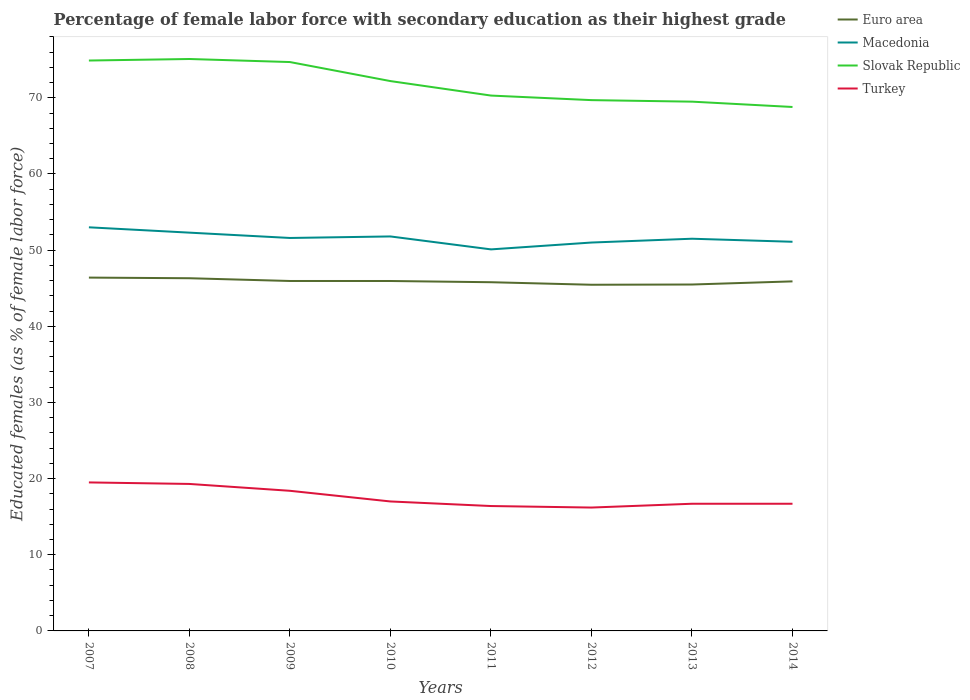How many different coloured lines are there?
Ensure brevity in your answer.  4. Does the line corresponding to Macedonia intersect with the line corresponding to Turkey?
Offer a very short reply. No. Across all years, what is the maximum percentage of female labor force with secondary education in Slovak Republic?
Keep it short and to the point. 68.8. What is the total percentage of female labor force with secondary education in Macedonia in the graph?
Offer a terse response. 1.4. What is the difference between the highest and the second highest percentage of female labor force with secondary education in Euro area?
Your answer should be compact. 0.94. What is the difference between the highest and the lowest percentage of female labor force with secondary education in Macedonia?
Your answer should be very brief. 4. Is the percentage of female labor force with secondary education in Slovak Republic strictly greater than the percentage of female labor force with secondary education in Euro area over the years?
Your response must be concise. No. What is the difference between two consecutive major ticks on the Y-axis?
Make the answer very short. 10. Does the graph contain grids?
Provide a short and direct response. No. Where does the legend appear in the graph?
Offer a very short reply. Top right. How are the legend labels stacked?
Offer a terse response. Vertical. What is the title of the graph?
Provide a short and direct response. Percentage of female labor force with secondary education as their highest grade. Does "San Marino" appear as one of the legend labels in the graph?
Your response must be concise. No. What is the label or title of the Y-axis?
Provide a short and direct response. Educated females (as % of female labor force). What is the Educated females (as % of female labor force) in Euro area in 2007?
Your answer should be very brief. 46.4. What is the Educated females (as % of female labor force) in Macedonia in 2007?
Keep it short and to the point. 53. What is the Educated females (as % of female labor force) of Slovak Republic in 2007?
Provide a succinct answer. 74.9. What is the Educated females (as % of female labor force) of Euro area in 2008?
Provide a succinct answer. 46.31. What is the Educated females (as % of female labor force) of Macedonia in 2008?
Your response must be concise. 52.3. What is the Educated females (as % of female labor force) in Slovak Republic in 2008?
Offer a terse response. 75.1. What is the Educated females (as % of female labor force) of Turkey in 2008?
Provide a short and direct response. 19.3. What is the Educated females (as % of female labor force) in Euro area in 2009?
Provide a short and direct response. 45.95. What is the Educated females (as % of female labor force) of Macedonia in 2009?
Make the answer very short. 51.6. What is the Educated females (as % of female labor force) in Slovak Republic in 2009?
Your answer should be very brief. 74.7. What is the Educated females (as % of female labor force) of Turkey in 2009?
Provide a succinct answer. 18.4. What is the Educated females (as % of female labor force) of Euro area in 2010?
Offer a very short reply. 45.95. What is the Educated females (as % of female labor force) in Macedonia in 2010?
Ensure brevity in your answer.  51.8. What is the Educated females (as % of female labor force) of Slovak Republic in 2010?
Make the answer very short. 72.2. What is the Educated females (as % of female labor force) in Euro area in 2011?
Provide a succinct answer. 45.79. What is the Educated females (as % of female labor force) in Macedonia in 2011?
Provide a succinct answer. 50.1. What is the Educated females (as % of female labor force) in Slovak Republic in 2011?
Ensure brevity in your answer.  70.3. What is the Educated females (as % of female labor force) in Turkey in 2011?
Make the answer very short. 16.4. What is the Educated females (as % of female labor force) in Euro area in 2012?
Offer a terse response. 45.46. What is the Educated females (as % of female labor force) of Macedonia in 2012?
Make the answer very short. 51. What is the Educated females (as % of female labor force) in Slovak Republic in 2012?
Ensure brevity in your answer.  69.7. What is the Educated females (as % of female labor force) of Turkey in 2012?
Your answer should be compact. 16.2. What is the Educated females (as % of female labor force) in Euro area in 2013?
Ensure brevity in your answer.  45.49. What is the Educated females (as % of female labor force) of Macedonia in 2013?
Give a very brief answer. 51.5. What is the Educated females (as % of female labor force) of Slovak Republic in 2013?
Provide a short and direct response. 69.5. What is the Educated females (as % of female labor force) in Turkey in 2013?
Keep it short and to the point. 16.7. What is the Educated females (as % of female labor force) in Euro area in 2014?
Your response must be concise. 45.9. What is the Educated females (as % of female labor force) of Macedonia in 2014?
Give a very brief answer. 51.1. What is the Educated females (as % of female labor force) in Slovak Republic in 2014?
Your answer should be compact. 68.8. What is the Educated females (as % of female labor force) in Turkey in 2014?
Ensure brevity in your answer.  16.7. Across all years, what is the maximum Educated females (as % of female labor force) in Euro area?
Ensure brevity in your answer.  46.4. Across all years, what is the maximum Educated females (as % of female labor force) in Macedonia?
Provide a short and direct response. 53. Across all years, what is the maximum Educated females (as % of female labor force) in Slovak Republic?
Your response must be concise. 75.1. Across all years, what is the maximum Educated females (as % of female labor force) of Turkey?
Provide a short and direct response. 19.5. Across all years, what is the minimum Educated females (as % of female labor force) of Euro area?
Keep it short and to the point. 45.46. Across all years, what is the minimum Educated females (as % of female labor force) in Macedonia?
Your response must be concise. 50.1. Across all years, what is the minimum Educated females (as % of female labor force) in Slovak Republic?
Give a very brief answer. 68.8. Across all years, what is the minimum Educated females (as % of female labor force) in Turkey?
Your answer should be very brief. 16.2. What is the total Educated females (as % of female labor force) of Euro area in the graph?
Your answer should be compact. 367.24. What is the total Educated females (as % of female labor force) of Macedonia in the graph?
Offer a terse response. 412.4. What is the total Educated females (as % of female labor force) in Slovak Republic in the graph?
Your answer should be compact. 575.2. What is the total Educated females (as % of female labor force) in Turkey in the graph?
Your answer should be very brief. 140.2. What is the difference between the Educated females (as % of female labor force) of Euro area in 2007 and that in 2008?
Your answer should be compact. 0.08. What is the difference between the Educated females (as % of female labor force) in Macedonia in 2007 and that in 2008?
Your answer should be compact. 0.7. What is the difference between the Educated females (as % of female labor force) in Slovak Republic in 2007 and that in 2008?
Offer a terse response. -0.2. What is the difference between the Educated females (as % of female labor force) in Turkey in 2007 and that in 2008?
Your response must be concise. 0.2. What is the difference between the Educated females (as % of female labor force) of Euro area in 2007 and that in 2009?
Ensure brevity in your answer.  0.44. What is the difference between the Educated females (as % of female labor force) in Slovak Republic in 2007 and that in 2009?
Provide a short and direct response. 0.2. What is the difference between the Educated females (as % of female labor force) in Euro area in 2007 and that in 2010?
Offer a very short reply. 0.45. What is the difference between the Educated females (as % of female labor force) in Slovak Republic in 2007 and that in 2010?
Offer a terse response. 2.7. What is the difference between the Educated females (as % of female labor force) in Turkey in 2007 and that in 2010?
Your answer should be very brief. 2.5. What is the difference between the Educated females (as % of female labor force) of Euro area in 2007 and that in 2011?
Your answer should be very brief. 0.61. What is the difference between the Educated females (as % of female labor force) in Turkey in 2007 and that in 2011?
Provide a short and direct response. 3.1. What is the difference between the Educated females (as % of female labor force) in Euro area in 2007 and that in 2012?
Provide a short and direct response. 0.94. What is the difference between the Educated females (as % of female labor force) of Turkey in 2007 and that in 2012?
Your response must be concise. 3.3. What is the difference between the Educated females (as % of female labor force) of Euro area in 2007 and that in 2013?
Offer a very short reply. 0.91. What is the difference between the Educated females (as % of female labor force) of Slovak Republic in 2007 and that in 2013?
Offer a very short reply. 5.4. What is the difference between the Educated females (as % of female labor force) in Turkey in 2007 and that in 2013?
Your answer should be very brief. 2.8. What is the difference between the Educated females (as % of female labor force) of Euro area in 2007 and that in 2014?
Provide a short and direct response. 0.5. What is the difference between the Educated females (as % of female labor force) in Macedonia in 2007 and that in 2014?
Provide a succinct answer. 1.9. What is the difference between the Educated females (as % of female labor force) of Turkey in 2007 and that in 2014?
Your answer should be very brief. 2.8. What is the difference between the Educated females (as % of female labor force) of Euro area in 2008 and that in 2009?
Offer a terse response. 0.36. What is the difference between the Educated females (as % of female labor force) in Slovak Republic in 2008 and that in 2009?
Your answer should be very brief. 0.4. What is the difference between the Educated females (as % of female labor force) in Turkey in 2008 and that in 2009?
Give a very brief answer. 0.9. What is the difference between the Educated females (as % of female labor force) of Euro area in 2008 and that in 2010?
Offer a terse response. 0.36. What is the difference between the Educated females (as % of female labor force) of Macedonia in 2008 and that in 2010?
Keep it short and to the point. 0.5. What is the difference between the Educated females (as % of female labor force) in Slovak Republic in 2008 and that in 2010?
Give a very brief answer. 2.9. What is the difference between the Educated females (as % of female labor force) in Turkey in 2008 and that in 2010?
Keep it short and to the point. 2.3. What is the difference between the Educated females (as % of female labor force) in Euro area in 2008 and that in 2011?
Offer a very short reply. 0.52. What is the difference between the Educated females (as % of female labor force) of Turkey in 2008 and that in 2011?
Your answer should be very brief. 2.9. What is the difference between the Educated females (as % of female labor force) in Euro area in 2008 and that in 2012?
Your answer should be compact. 0.86. What is the difference between the Educated females (as % of female labor force) in Euro area in 2008 and that in 2013?
Your response must be concise. 0.83. What is the difference between the Educated females (as % of female labor force) of Macedonia in 2008 and that in 2013?
Make the answer very short. 0.8. What is the difference between the Educated females (as % of female labor force) of Euro area in 2008 and that in 2014?
Your response must be concise. 0.41. What is the difference between the Educated females (as % of female labor force) in Macedonia in 2008 and that in 2014?
Ensure brevity in your answer.  1.2. What is the difference between the Educated females (as % of female labor force) of Turkey in 2008 and that in 2014?
Your answer should be very brief. 2.6. What is the difference between the Educated females (as % of female labor force) of Euro area in 2009 and that in 2010?
Provide a short and direct response. 0. What is the difference between the Educated females (as % of female labor force) in Slovak Republic in 2009 and that in 2010?
Provide a succinct answer. 2.5. What is the difference between the Educated females (as % of female labor force) of Turkey in 2009 and that in 2010?
Provide a short and direct response. 1.4. What is the difference between the Educated females (as % of female labor force) of Euro area in 2009 and that in 2011?
Ensure brevity in your answer.  0.16. What is the difference between the Educated females (as % of female labor force) of Macedonia in 2009 and that in 2011?
Offer a terse response. 1.5. What is the difference between the Educated females (as % of female labor force) in Slovak Republic in 2009 and that in 2011?
Provide a succinct answer. 4.4. What is the difference between the Educated females (as % of female labor force) of Euro area in 2009 and that in 2012?
Offer a very short reply. 0.5. What is the difference between the Educated females (as % of female labor force) in Slovak Republic in 2009 and that in 2012?
Your answer should be very brief. 5. What is the difference between the Educated females (as % of female labor force) of Euro area in 2009 and that in 2013?
Keep it short and to the point. 0.46. What is the difference between the Educated females (as % of female labor force) of Turkey in 2009 and that in 2013?
Your answer should be very brief. 1.7. What is the difference between the Educated females (as % of female labor force) of Euro area in 2009 and that in 2014?
Your response must be concise. 0.05. What is the difference between the Educated females (as % of female labor force) of Slovak Republic in 2009 and that in 2014?
Your response must be concise. 5.9. What is the difference between the Educated females (as % of female labor force) in Euro area in 2010 and that in 2011?
Offer a very short reply. 0.16. What is the difference between the Educated females (as % of female labor force) of Macedonia in 2010 and that in 2011?
Your answer should be very brief. 1.7. What is the difference between the Educated females (as % of female labor force) in Slovak Republic in 2010 and that in 2011?
Provide a short and direct response. 1.9. What is the difference between the Educated females (as % of female labor force) in Euro area in 2010 and that in 2012?
Make the answer very short. 0.49. What is the difference between the Educated females (as % of female labor force) in Macedonia in 2010 and that in 2012?
Offer a very short reply. 0.8. What is the difference between the Educated females (as % of female labor force) of Turkey in 2010 and that in 2012?
Your response must be concise. 0.8. What is the difference between the Educated females (as % of female labor force) of Euro area in 2010 and that in 2013?
Provide a succinct answer. 0.46. What is the difference between the Educated females (as % of female labor force) in Euro area in 2010 and that in 2014?
Make the answer very short. 0.05. What is the difference between the Educated females (as % of female labor force) of Turkey in 2010 and that in 2014?
Your response must be concise. 0.3. What is the difference between the Educated females (as % of female labor force) in Euro area in 2011 and that in 2012?
Provide a short and direct response. 0.33. What is the difference between the Educated females (as % of female labor force) in Slovak Republic in 2011 and that in 2012?
Make the answer very short. 0.6. What is the difference between the Educated females (as % of female labor force) of Turkey in 2011 and that in 2012?
Ensure brevity in your answer.  0.2. What is the difference between the Educated females (as % of female labor force) of Euro area in 2011 and that in 2013?
Ensure brevity in your answer.  0.3. What is the difference between the Educated females (as % of female labor force) in Macedonia in 2011 and that in 2013?
Make the answer very short. -1.4. What is the difference between the Educated females (as % of female labor force) in Slovak Republic in 2011 and that in 2013?
Your answer should be compact. 0.8. What is the difference between the Educated females (as % of female labor force) in Turkey in 2011 and that in 2013?
Your answer should be compact. -0.3. What is the difference between the Educated females (as % of female labor force) in Euro area in 2011 and that in 2014?
Keep it short and to the point. -0.11. What is the difference between the Educated females (as % of female labor force) in Macedonia in 2011 and that in 2014?
Offer a terse response. -1. What is the difference between the Educated females (as % of female labor force) of Turkey in 2011 and that in 2014?
Your response must be concise. -0.3. What is the difference between the Educated females (as % of female labor force) of Euro area in 2012 and that in 2013?
Your answer should be compact. -0.03. What is the difference between the Educated females (as % of female labor force) of Turkey in 2012 and that in 2013?
Your answer should be compact. -0.5. What is the difference between the Educated females (as % of female labor force) in Euro area in 2012 and that in 2014?
Keep it short and to the point. -0.44. What is the difference between the Educated females (as % of female labor force) of Slovak Republic in 2012 and that in 2014?
Your answer should be very brief. 0.9. What is the difference between the Educated females (as % of female labor force) in Euro area in 2013 and that in 2014?
Make the answer very short. -0.41. What is the difference between the Educated females (as % of female labor force) in Slovak Republic in 2013 and that in 2014?
Give a very brief answer. 0.7. What is the difference between the Educated females (as % of female labor force) of Turkey in 2013 and that in 2014?
Offer a terse response. 0. What is the difference between the Educated females (as % of female labor force) in Euro area in 2007 and the Educated females (as % of female labor force) in Macedonia in 2008?
Give a very brief answer. -5.9. What is the difference between the Educated females (as % of female labor force) in Euro area in 2007 and the Educated females (as % of female labor force) in Slovak Republic in 2008?
Ensure brevity in your answer.  -28.7. What is the difference between the Educated females (as % of female labor force) of Euro area in 2007 and the Educated females (as % of female labor force) of Turkey in 2008?
Offer a terse response. 27.1. What is the difference between the Educated females (as % of female labor force) in Macedonia in 2007 and the Educated females (as % of female labor force) in Slovak Republic in 2008?
Ensure brevity in your answer.  -22.1. What is the difference between the Educated females (as % of female labor force) in Macedonia in 2007 and the Educated females (as % of female labor force) in Turkey in 2008?
Offer a very short reply. 33.7. What is the difference between the Educated females (as % of female labor force) of Slovak Republic in 2007 and the Educated females (as % of female labor force) of Turkey in 2008?
Provide a short and direct response. 55.6. What is the difference between the Educated females (as % of female labor force) in Euro area in 2007 and the Educated females (as % of female labor force) in Macedonia in 2009?
Ensure brevity in your answer.  -5.2. What is the difference between the Educated females (as % of female labor force) in Euro area in 2007 and the Educated females (as % of female labor force) in Slovak Republic in 2009?
Your answer should be very brief. -28.3. What is the difference between the Educated females (as % of female labor force) in Euro area in 2007 and the Educated females (as % of female labor force) in Turkey in 2009?
Offer a terse response. 28. What is the difference between the Educated females (as % of female labor force) of Macedonia in 2007 and the Educated females (as % of female labor force) of Slovak Republic in 2009?
Keep it short and to the point. -21.7. What is the difference between the Educated females (as % of female labor force) of Macedonia in 2007 and the Educated females (as % of female labor force) of Turkey in 2009?
Your answer should be very brief. 34.6. What is the difference between the Educated females (as % of female labor force) of Slovak Republic in 2007 and the Educated females (as % of female labor force) of Turkey in 2009?
Make the answer very short. 56.5. What is the difference between the Educated females (as % of female labor force) in Euro area in 2007 and the Educated females (as % of female labor force) in Macedonia in 2010?
Your answer should be compact. -5.4. What is the difference between the Educated females (as % of female labor force) of Euro area in 2007 and the Educated females (as % of female labor force) of Slovak Republic in 2010?
Offer a terse response. -25.8. What is the difference between the Educated females (as % of female labor force) in Euro area in 2007 and the Educated females (as % of female labor force) in Turkey in 2010?
Make the answer very short. 29.4. What is the difference between the Educated females (as % of female labor force) of Macedonia in 2007 and the Educated females (as % of female labor force) of Slovak Republic in 2010?
Your response must be concise. -19.2. What is the difference between the Educated females (as % of female labor force) in Macedonia in 2007 and the Educated females (as % of female labor force) in Turkey in 2010?
Your answer should be compact. 36. What is the difference between the Educated females (as % of female labor force) of Slovak Republic in 2007 and the Educated females (as % of female labor force) of Turkey in 2010?
Provide a succinct answer. 57.9. What is the difference between the Educated females (as % of female labor force) of Euro area in 2007 and the Educated females (as % of female labor force) of Macedonia in 2011?
Your answer should be compact. -3.7. What is the difference between the Educated females (as % of female labor force) of Euro area in 2007 and the Educated females (as % of female labor force) of Slovak Republic in 2011?
Ensure brevity in your answer.  -23.9. What is the difference between the Educated females (as % of female labor force) in Euro area in 2007 and the Educated females (as % of female labor force) in Turkey in 2011?
Ensure brevity in your answer.  30. What is the difference between the Educated females (as % of female labor force) in Macedonia in 2007 and the Educated females (as % of female labor force) in Slovak Republic in 2011?
Your answer should be very brief. -17.3. What is the difference between the Educated females (as % of female labor force) of Macedonia in 2007 and the Educated females (as % of female labor force) of Turkey in 2011?
Give a very brief answer. 36.6. What is the difference between the Educated females (as % of female labor force) in Slovak Republic in 2007 and the Educated females (as % of female labor force) in Turkey in 2011?
Offer a very short reply. 58.5. What is the difference between the Educated females (as % of female labor force) in Euro area in 2007 and the Educated females (as % of female labor force) in Macedonia in 2012?
Your answer should be compact. -4.6. What is the difference between the Educated females (as % of female labor force) of Euro area in 2007 and the Educated females (as % of female labor force) of Slovak Republic in 2012?
Offer a terse response. -23.3. What is the difference between the Educated females (as % of female labor force) of Euro area in 2007 and the Educated females (as % of female labor force) of Turkey in 2012?
Give a very brief answer. 30.2. What is the difference between the Educated females (as % of female labor force) in Macedonia in 2007 and the Educated females (as % of female labor force) in Slovak Republic in 2012?
Make the answer very short. -16.7. What is the difference between the Educated females (as % of female labor force) in Macedonia in 2007 and the Educated females (as % of female labor force) in Turkey in 2012?
Your answer should be compact. 36.8. What is the difference between the Educated females (as % of female labor force) of Slovak Republic in 2007 and the Educated females (as % of female labor force) of Turkey in 2012?
Offer a terse response. 58.7. What is the difference between the Educated females (as % of female labor force) in Euro area in 2007 and the Educated females (as % of female labor force) in Macedonia in 2013?
Provide a succinct answer. -5.1. What is the difference between the Educated females (as % of female labor force) in Euro area in 2007 and the Educated females (as % of female labor force) in Slovak Republic in 2013?
Make the answer very short. -23.1. What is the difference between the Educated females (as % of female labor force) in Euro area in 2007 and the Educated females (as % of female labor force) in Turkey in 2013?
Offer a very short reply. 29.7. What is the difference between the Educated females (as % of female labor force) of Macedonia in 2007 and the Educated females (as % of female labor force) of Slovak Republic in 2013?
Provide a succinct answer. -16.5. What is the difference between the Educated females (as % of female labor force) of Macedonia in 2007 and the Educated females (as % of female labor force) of Turkey in 2013?
Keep it short and to the point. 36.3. What is the difference between the Educated females (as % of female labor force) of Slovak Republic in 2007 and the Educated females (as % of female labor force) of Turkey in 2013?
Provide a succinct answer. 58.2. What is the difference between the Educated females (as % of female labor force) of Euro area in 2007 and the Educated females (as % of female labor force) of Macedonia in 2014?
Provide a succinct answer. -4.7. What is the difference between the Educated females (as % of female labor force) of Euro area in 2007 and the Educated females (as % of female labor force) of Slovak Republic in 2014?
Your answer should be very brief. -22.4. What is the difference between the Educated females (as % of female labor force) in Euro area in 2007 and the Educated females (as % of female labor force) in Turkey in 2014?
Offer a very short reply. 29.7. What is the difference between the Educated females (as % of female labor force) in Macedonia in 2007 and the Educated females (as % of female labor force) in Slovak Republic in 2014?
Offer a very short reply. -15.8. What is the difference between the Educated females (as % of female labor force) of Macedonia in 2007 and the Educated females (as % of female labor force) of Turkey in 2014?
Your response must be concise. 36.3. What is the difference between the Educated females (as % of female labor force) of Slovak Republic in 2007 and the Educated females (as % of female labor force) of Turkey in 2014?
Provide a short and direct response. 58.2. What is the difference between the Educated females (as % of female labor force) in Euro area in 2008 and the Educated females (as % of female labor force) in Macedonia in 2009?
Provide a succinct answer. -5.29. What is the difference between the Educated females (as % of female labor force) in Euro area in 2008 and the Educated females (as % of female labor force) in Slovak Republic in 2009?
Your answer should be compact. -28.39. What is the difference between the Educated females (as % of female labor force) in Euro area in 2008 and the Educated females (as % of female labor force) in Turkey in 2009?
Offer a very short reply. 27.91. What is the difference between the Educated females (as % of female labor force) of Macedonia in 2008 and the Educated females (as % of female labor force) of Slovak Republic in 2009?
Your answer should be compact. -22.4. What is the difference between the Educated females (as % of female labor force) in Macedonia in 2008 and the Educated females (as % of female labor force) in Turkey in 2009?
Provide a short and direct response. 33.9. What is the difference between the Educated females (as % of female labor force) in Slovak Republic in 2008 and the Educated females (as % of female labor force) in Turkey in 2009?
Offer a very short reply. 56.7. What is the difference between the Educated females (as % of female labor force) in Euro area in 2008 and the Educated females (as % of female labor force) in Macedonia in 2010?
Offer a very short reply. -5.49. What is the difference between the Educated females (as % of female labor force) of Euro area in 2008 and the Educated females (as % of female labor force) of Slovak Republic in 2010?
Provide a short and direct response. -25.89. What is the difference between the Educated females (as % of female labor force) of Euro area in 2008 and the Educated females (as % of female labor force) of Turkey in 2010?
Provide a succinct answer. 29.31. What is the difference between the Educated females (as % of female labor force) in Macedonia in 2008 and the Educated females (as % of female labor force) in Slovak Republic in 2010?
Offer a terse response. -19.9. What is the difference between the Educated females (as % of female labor force) of Macedonia in 2008 and the Educated females (as % of female labor force) of Turkey in 2010?
Give a very brief answer. 35.3. What is the difference between the Educated females (as % of female labor force) of Slovak Republic in 2008 and the Educated females (as % of female labor force) of Turkey in 2010?
Your answer should be compact. 58.1. What is the difference between the Educated females (as % of female labor force) of Euro area in 2008 and the Educated females (as % of female labor force) of Macedonia in 2011?
Offer a terse response. -3.79. What is the difference between the Educated females (as % of female labor force) in Euro area in 2008 and the Educated females (as % of female labor force) in Slovak Republic in 2011?
Provide a succinct answer. -23.99. What is the difference between the Educated females (as % of female labor force) in Euro area in 2008 and the Educated females (as % of female labor force) in Turkey in 2011?
Give a very brief answer. 29.91. What is the difference between the Educated females (as % of female labor force) of Macedonia in 2008 and the Educated females (as % of female labor force) of Turkey in 2011?
Provide a short and direct response. 35.9. What is the difference between the Educated females (as % of female labor force) in Slovak Republic in 2008 and the Educated females (as % of female labor force) in Turkey in 2011?
Provide a short and direct response. 58.7. What is the difference between the Educated females (as % of female labor force) in Euro area in 2008 and the Educated females (as % of female labor force) in Macedonia in 2012?
Your answer should be compact. -4.69. What is the difference between the Educated females (as % of female labor force) in Euro area in 2008 and the Educated females (as % of female labor force) in Slovak Republic in 2012?
Keep it short and to the point. -23.39. What is the difference between the Educated females (as % of female labor force) in Euro area in 2008 and the Educated females (as % of female labor force) in Turkey in 2012?
Provide a succinct answer. 30.11. What is the difference between the Educated females (as % of female labor force) in Macedonia in 2008 and the Educated females (as % of female labor force) in Slovak Republic in 2012?
Your answer should be very brief. -17.4. What is the difference between the Educated females (as % of female labor force) of Macedonia in 2008 and the Educated females (as % of female labor force) of Turkey in 2012?
Your answer should be compact. 36.1. What is the difference between the Educated females (as % of female labor force) of Slovak Republic in 2008 and the Educated females (as % of female labor force) of Turkey in 2012?
Give a very brief answer. 58.9. What is the difference between the Educated females (as % of female labor force) of Euro area in 2008 and the Educated females (as % of female labor force) of Macedonia in 2013?
Your answer should be compact. -5.19. What is the difference between the Educated females (as % of female labor force) of Euro area in 2008 and the Educated females (as % of female labor force) of Slovak Republic in 2013?
Keep it short and to the point. -23.19. What is the difference between the Educated females (as % of female labor force) in Euro area in 2008 and the Educated females (as % of female labor force) in Turkey in 2013?
Make the answer very short. 29.61. What is the difference between the Educated females (as % of female labor force) in Macedonia in 2008 and the Educated females (as % of female labor force) in Slovak Republic in 2013?
Offer a terse response. -17.2. What is the difference between the Educated females (as % of female labor force) in Macedonia in 2008 and the Educated females (as % of female labor force) in Turkey in 2013?
Your response must be concise. 35.6. What is the difference between the Educated females (as % of female labor force) of Slovak Republic in 2008 and the Educated females (as % of female labor force) of Turkey in 2013?
Your response must be concise. 58.4. What is the difference between the Educated females (as % of female labor force) of Euro area in 2008 and the Educated females (as % of female labor force) of Macedonia in 2014?
Offer a very short reply. -4.79. What is the difference between the Educated females (as % of female labor force) in Euro area in 2008 and the Educated females (as % of female labor force) in Slovak Republic in 2014?
Your answer should be very brief. -22.49. What is the difference between the Educated females (as % of female labor force) in Euro area in 2008 and the Educated females (as % of female labor force) in Turkey in 2014?
Provide a succinct answer. 29.61. What is the difference between the Educated females (as % of female labor force) of Macedonia in 2008 and the Educated females (as % of female labor force) of Slovak Republic in 2014?
Your answer should be compact. -16.5. What is the difference between the Educated females (as % of female labor force) in Macedonia in 2008 and the Educated females (as % of female labor force) in Turkey in 2014?
Provide a short and direct response. 35.6. What is the difference between the Educated females (as % of female labor force) of Slovak Republic in 2008 and the Educated females (as % of female labor force) of Turkey in 2014?
Give a very brief answer. 58.4. What is the difference between the Educated females (as % of female labor force) of Euro area in 2009 and the Educated females (as % of female labor force) of Macedonia in 2010?
Keep it short and to the point. -5.85. What is the difference between the Educated females (as % of female labor force) in Euro area in 2009 and the Educated females (as % of female labor force) in Slovak Republic in 2010?
Your answer should be compact. -26.25. What is the difference between the Educated females (as % of female labor force) in Euro area in 2009 and the Educated females (as % of female labor force) in Turkey in 2010?
Ensure brevity in your answer.  28.95. What is the difference between the Educated females (as % of female labor force) of Macedonia in 2009 and the Educated females (as % of female labor force) of Slovak Republic in 2010?
Offer a terse response. -20.6. What is the difference between the Educated females (as % of female labor force) in Macedonia in 2009 and the Educated females (as % of female labor force) in Turkey in 2010?
Provide a short and direct response. 34.6. What is the difference between the Educated females (as % of female labor force) in Slovak Republic in 2009 and the Educated females (as % of female labor force) in Turkey in 2010?
Keep it short and to the point. 57.7. What is the difference between the Educated females (as % of female labor force) of Euro area in 2009 and the Educated females (as % of female labor force) of Macedonia in 2011?
Ensure brevity in your answer.  -4.15. What is the difference between the Educated females (as % of female labor force) of Euro area in 2009 and the Educated females (as % of female labor force) of Slovak Republic in 2011?
Provide a succinct answer. -24.35. What is the difference between the Educated females (as % of female labor force) in Euro area in 2009 and the Educated females (as % of female labor force) in Turkey in 2011?
Give a very brief answer. 29.55. What is the difference between the Educated females (as % of female labor force) of Macedonia in 2009 and the Educated females (as % of female labor force) of Slovak Republic in 2011?
Ensure brevity in your answer.  -18.7. What is the difference between the Educated females (as % of female labor force) of Macedonia in 2009 and the Educated females (as % of female labor force) of Turkey in 2011?
Your answer should be compact. 35.2. What is the difference between the Educated females (as % of female labor force) in Slovak Republic in 2009 and the Educated females (as % of female labor force) in Turkey in 2011?
Your answer should be very brief. 58.3. What is the difference between the Educated females (as % of female labor force) of Euro area in 2009 and the Educated females (as % of female labor force) of Macedonia in 2012?
Your answer should be compact. -5.05. What is the difference between the Educated females (as % of female labor force) in Euro area in 2009 and the Educated females (as % of female labor force) in Slovak Republic in 2012?
Offer a terse response. -23.75. What is the difference between the Educated females (as % of female labor force) of Euro area in 2009 and the Educated females (as % of female labor force) of Turkey in 2012?
Your answer should be very brief. 29.75. What is the difference between the Educated females (as % of female labor force) of Macedonia in 2009 and the Educated females (as % of female labor force) of Slovak Republic in 2012?
Give a very brief answer. -18.1. What is the difference between the Educated females (as % of female labor force) in Macedonia in 2009 and the Educated females (as % of female labor force) in Turkey in 2012?
Ensure brevity in your answer.  35.4. What is the difference between the Educated females (as % of female labor force) of Slovak Republic in 2009 and the Educated females (as % of female labor force) of Turkey in 2012?
Make the answer very short. 58.5. What is the difference between the Educated females (as % of female labor force) of Euro area in 2009 and the Educated females (as % of female labor force) of Macedonia in 2013?
Your response must be concise. -5.55. What is the difference between the Educated females (as % of female labor force) in Euro area in 2009 and the Educated females (as % of female labor force) in Slovak Republic in 2013?
Ensure brevity in your answer.  -23.55. What is the difference between the Educated females (as % of female labor force) in Euro area in 2009 and the Educated females (as % of female labor force) in Turkey in 2013?
Offer a terse response. 29.25. What is the difference between the Educated females (as % of female labor force) in Macedonia in 2009 and the Educated females (as % of female labor force) in Slovak Republic in 2013?
Your answer should be compact. -17.9. What is the difference between the Educated females (as % of female labor force) in Macedonia in 2009 and the Educated females (as % of female labor force) in Turkey in 2013?
Offer a very short reply. 34.9. What is the difference between the Educated females (as % of female labor force) in Euro area in 2009 and the Educated females (as % of female labor force) in Macedonia in 2014?
Keep it short and to the point. -5.15. What is the difference between the Educated females (as % of female labor force) of Euro area in 2009 and the Educated females (as % of female labor force) of Slovak Republic in 2014?
Keep it short and to the point. -22.85. What is the difference between the Educated females (as % of female labor force) in Euro area in 2009 and the Educated females (as % of female labor force) in Turkey in 2014?
Offer a very short reply. 29.25. What is the difference between the Educated females (as % of female labor force) of Macedonia in 2009 and the Educated females (as % of female labor force) of Slovak Republic in 2014?
Your answer should be very brief. -17.2. What is the difference between the Educated females (as % of female labor force) in Macedonia in 2009 and the Educated females (as % of female labor force) in Turkey in 2014?
Offer a terse response. 34.9. What is the difference between the Educated females (as % of female labor force) of Euro area in 2010 and the Educated females (as % of female labor force) of Macedonia in 2011?
Ensure brevity in your answer.  -4.15. What is the difference between the Educated females (as % of female labor force) in Euro area in 2010 and the Educated females (as % of female labor force) in Slovak Republic in 2011?
Your answer should be very brief. -24.35. What is the difference between the Educated females (as % of female labor force) of Euro area in 2010 and the Educated females (as % of female labor force) of Turkey in 2011?
Provide a succinct answer. 29.55. What is the difference between the Educated females (as % of female labor force) in Macedonia in 2010 and the Educated females (as % of female labor force) in Slovak Republic in 2011?
Provide a short and direct response. -18.5. What is the difference between the Educated females (as % of female labor force) of Macedonia in 2010 and the Educated females (as % of female labor force) of Turkey in 2011?
Provide a succinct answer. 35.4. What is the difference between the Educated females (as % of female labor force) of Slovak Republic in 2010 and the Educated females (as % of female labor force) of Turkey in 2011?
Make the answer very short. 55.8. What is the difference between the Educated females (as % of female labor force) of Euro area in 2010 and the Educated females (as % of female labor force) of Macedonia in 2012?
Offer a very short reply. -5.05. What is the difference between the Educated females (as % of female labor force) in Euro area in 2010 and the Educated females (as % of female labor force) in Slovak Republic in 2012?
Ensure brevity in your answer.  -23.75. What is the difference between the Educated females (as % of female labor force) of Euro area in 2010 and the Educated females (as % of female labor force) of Turkey in 2012?
Offer a very short reply. 29.75. What is the difference between the Educated females (as % of female labor force) in Macedonia in 2010 and the Educated females (as % of female labor force) in Slovak Republic in 2012?
Provide a succinct answer. -17.9. What is the difference between the Educated females (as % of female labor force) of Macedonia in 2010 and the Educated females (as % of female labor force) of Turkey in 2012?
Ensure brevity in your answer.  35.6. What is the difference between the Educated females (as % of female labor force) of Euro area in 2010 and the Educated females (as % of female labor force) of Macedonia in 2013?
Offer a terse response. -5.55. What is the difference between the Educated females (as % of female labor force) of Euro area in 2010 and the Educated females (as % of female labor force) of Slovak Republic in 2013?
Keep it short and to the point. -23.55. What is the difference between the Educated females (as % of female labor force) of Euro area in 2010 and the Educated females (as % of female labor force) of Turkey in 2013?
Make the answer very short. 29.25. What is the difference between the Educated females (as % of female labor force) in Macedonia in 2010 and the Educated females (as % of female labor force) in Slovak Republic in 2013?
Your answer should be compact. -17.7. What is the difference between the Educated females (as % of female labor force) in Macedonia in 2010 and the Educated females (as % of female labor force) in Turkey in 2013?
Offer a terse response. 35.1. What is the difference between the Educated females (as % of female labor force) of Slovak Republic in 2010 and the Educated females (as % of female labor force) of Turkey in 2013?
Keep it short and to the point. 55.5. What is the difference between the Educated females (as % of female labor force) of Euro area in 2010 and the Educated females (as % of female labor force) of Macedonia in 2014?
Your answer should be compact. -5.15. What is the difference between the Educated females (as % of female labor force) in Euro area in 2010 and the Educated females (as % of female labor force) in Slovak Republic in 2014?
Make the answer very short. -22.85. What is the difference between the Educated females (as % of female labor force) of Euro area in 2010 and the Educated females (as % of female labor force) of Turkey in 2014?
Offer a very short reply. 29.25. What is the difference between the Educated females (as % of female labor force) of Macedonia in 2010 and the Educated females (as % of female labor force) of Turkey in 2014?
Give a very brief answer. 35.1. What is the difference between the Educated females (as % of female labor force) in Slovak Republic in 2010 and the Educated females (as % of female labor force) in Turkey in 2014?
Provide a short and direct response. 55.5. What is the difference between the Educated females (as % of female labor force) in Euro area in 2011 and the Educated females (as % of female labor force) in Macedonia in 2012?
Your response must be concise. -5.21. What is the difference between the Educated females (as % of female labor force) in Euro area in 2011 and the Educated females (as % of female labor force) in Slovak Republic in 2012?
Your answer should be compact. -23.91. What is the difference between the Educated females (as % of female labor force) of Euro area in 2011 and the Educated females (as % of female labor force) of Turkey in 2012?
Your answer should be very brief. 29.59. What is the difference between the Educated females (as % of female labor force) of Macedonia in 2011 and the Educated females (as % of female labor force) of Slovak Republic in 2012?
Make the answer very short. -19.6. What is the difference between the Educated females (as % of female labor force) of Macedonia in 2011 and the Educated females (as % of female labor force) of Turkey in 2012?
Keep it short and to the point. 33.9. What is the difference between the Educated females (as % of female labor force) in Slovak Republic in 2011 and the Educated females (as % of female labor force) in Turkey in 2012?
Give a very brief answer. 54.1. What is the difference between the Educated females (as % of female labor force) of Euro area in 2011 and the Educated females (as % of female labor force) of Macedonia in 2013?
Offer a terse response. -5.71. What is the difference between the Educated females (as % of female labor force) of Euro area in 2011 and the Educated females (as % of female labor force) of Slovak Republic in 2013?
Provide a succinct answer. -23.71. What is the difference between the Educated females (as % of female labor force) in Euro area in 2011 and the Educated females (as % of female labor force) in Turkey in 2013?
Your answer should be very brief. 29.09. What is the difference between the Educated females (as % of female labor force) of Macedonia in 2011 and the Educated females (as % of female labor force) of Slovak Republic in 2013?
Keep it short and to the point. -19.4. What is the difference between the Educated females (as % of female labor force) of Macedonia in 2011 and the Educated females (as % of female labor force) of Turkey in 2013?
Ensure brevity in your answer.  33.4. What is the difference between the Educated females (as % of female labor force) of Slovak Republic in 2011 and the Educated females (as % of female labor force) of Turkey in 2013?
Keep it short and to the point. 53.6. What is the difference between the Educated females (as % of female labor force) in Euro area in 2011 and the Educated females (as % of female labor force) in Macedonia in 2014?
Provide a short and direct response. -5.31. What is the difference between the Educated females (as % of female labor force) of Euro area in 2011 and the Educated females (as % of female labor force) of Slovak Republic in 2014?
Keep it short and to the point. -23.01. What is the difference between the Educated females (as % of female labor force) of Euro area in 2011 and the Educated females (as % of female labor force) of Turkey in 2014?
Make the answer very short. 29.09. What is the difference between the Educated females (as % of female labor force) of Macedonia in 2011 and the Educated females (as % of female labor force) of Slovak Republic in 2014?
Your answer should be compact. -18.7. What is the difference between the Educated females (as % of female labor force) of Macedonia in 2011 and the Educated females (as % of female labor force) of Turkey in 2014?
Keep it short and to the point. 33.4. What is the difference between the Educated females (as % of female labor force) in Slovak Republic in 2011 and the Educated females (as % of female labor force) in Turkey in 2014?
Your answer should be very brief. 53.6. What is the difference between the Educated females (as % of female labor force) in Euro area in 2012 and the Educated females (as % of female labor force) in Macedonia in 2013?
Keep it short and to the point. -6.04. What is the difference between the Educated females (as % of female labor force) in Euro area in 2012 and the Educated females (as % of female labor force) in Slovak Republic in 2013?
Your answer should be compact. -24.04. What is the difference between the Educated females (as % of female labor force) in Euro area in 2012 and the Educated females (as % of female labor force) in Turkey in 2013?
Your answer should be compact. 28.76. What is the difference between the Educated females (as % of female labor force) in Macedonia in 2012 and the Educated females (as % of female labor force) in Slovak Republic in 2013?
Keep it short and to the point. -18.5. What is the difference between the Educated females (as % of female labor force) of Macedonia in 2012 and the Educated females (as % of female labor force) of Turkey in 2013?
Offer a terse response. 34.3. What is the difference between the Educated females (as % of female labor force) of Euro area in 2012 and the Educated females (as % of female labor force) of Macedonia in 2014?
Offer a terse response. -5.64. What is the difference between the Educated females (as % of female labor force) of Euro area in 2012 and the Educated females (as % of female labor force) of Slovak Republic in 2014?
Provide a short and direct response. -23.34. What is the difference between the Educated females (as % of female labor force) of Euro area in 2012 and the Educated females (as % of female labor force) of Turkey in 2014?
Give a very brief answer. 28.76. What is the difference between the Educated females (as % of female labor force) in Macedonia in 2012 and the Educated females (as % of female labor force) in Slovak Republic in 2014?
Ensure brevity in your answer.  -17.8. What is the difference between the Educated females (as % of female labor force) of Macedonia in 2012 and the Educated females (as % of female labor force) of Turkey in 2014?
Offer a very short reply. 34.3. What is the difference between the Educated females (as % of female labor force) of Slovak Republic in 2012 and the Educated females (as % of female labor force) of Turkey in 2014?
Provide a short and direct response. 53. What is the difference between the Educated females (as % of female labor force) of Euro area in 2013 and the Educated females (as % of female labor force) of Macedonia in 2014?
Your response must be concise. -5.61. What is the difference between the Educated females (as % of female labor force) of Euro area in 2013 and the Educated females (as % of female labor force) of Slovak Republic in 2014?
Provide a short and direct response. -23.31. What is the difference between the Educated females (as % of female labor force) in Euro area in 2013 and the Educated females (as % of female labor force) in Turkey in 2014?
Your answer should be very brief. 28.79. What is the difference between the Educated females (as % of female labor force) of Macedonia in 2013 and the Educated females (as % of female labor force) of Slovak Republic in 2014?
Make the answer very short. -17.3. What is the difference between the Educated females (as % of female labor force) in Macedonia in 2013 and the Educated females (as % of female labor force) in Turkey in 2014?
Offer a terse response. 34.8. What is the difference between the Educated females (as % of female labor force) of Slovak Republic in 2013 and the Educated females (as % of female labor force) of Turkey in 2014?
Keep it short and to the point. 52.8. What is the average Educated females (as % of female labor force) of Euro area per year?
Offer a terse response. 45.91. What is the average Educated females (as % of female labor force) in Macedonia per year?
Give a very brief answer. 51.55. What is the average Educated females (as % of female labor force) in Slovak Republic per year?
Your answer should be very brief. 71.9. What is the average Educated females (as % of female labor force) of Turkey per year?
Give a very brief answer. 17.52. In the year 2007, what is the difference between the Educated females (as % of female labor force) in Euro area and Educated females (as % of female labor force) in Macedonia?
Provide a succinct answer. -6.6. In the year 2007, what is the difference between the Educated females (as % of female labor force) of Euro area and Educated females (as % of female labor force) of Slovak Republic?
Offer a terse response. -28.5. In the year 2007, what is the difference between the Educated females (as % of female labor force) of Euro area and Educated females (as % of female labor force) of Turkey?
Provide a succinct answer. 26.9. In the year 2007, what is the difference between the Educated females (as % of female labor force) in Macedonia and Educated females (as % of female labor force) in Slovak Republic?
Offer a very short reply. -21.9. In the year 2007, what is the difference between the Educated females (as % of female labor force) in Macedonia and Educated females (as % of female labor force) in Turkey?
Offer a very short reply. 33.5. In the year 2007, what is the difference between the Educated females (as % of female labor force) in Slovak Republic and Educated females (as % of female labor force) in Turkey?
Your response must be concise. 55.4. In the year 2008, what is the difference between the Educated females (as % of female labor force) in Euro area and Educated females (as % of female labor force) in Macedonia?
Provide a short and direct response. -5.99. In the year 2008, what is the difference between the Educated females (as % of female labor force) of Euro area and Educated females (as % of female labor force) of Slovak Republic?
Your answer should be compact. -28.79. In the year 2008, what is the difference between the Educated females (as % of female labor force) of Euro area and Educated females (as % of female labor force) of Turkey?
Give a very brief answer. 27.01. In the year 2008, what is the difference between the Educated females (as % of female labor force) in Macedonia and Educated females (as % of female labor force) in Slovak Republic?
Offer a terse response. -22.8. In the year 2008, what is the difference between the Educated females (as % of female labor force) in Macedonia and Educated females (as % of female labor force) in Turkey?
Give a very brief answer. 33. In the year 2008, what is the difference between the Educated females (as % of female labor force) in Slovak Republic and Educated females (as % of female labor force) in Turkey?
Provide a succinct answer. 55.8. In the year 2009, what is the difference between the Educated females (as % of female labor force) of Euro area and Educated females (as % of female labor force) of Macedonia?
Offer a terse response. -5.65. In the year 2009, what is the difference between the Educated females (as % of female labor force) of Euro area and Educated females (as % of female labor force) of Slovak Republic?
Your response must be concise. -28.75. In the year 2009, what is the difference between the Educated females (as % of female labor force) of Euro area and Educated females (as % of female labor force) of Turkey?
Make the answer very short. 27.55. In the year 2009, what is the difference between the Educated females (as % of female labor force) of Macedonia and Educated females (as % of female labor force) of Slovak Republic?
Your answer should be very brief. -23.1. In the year 2009, what is the difference between the Educated females (as % of female labor force) in Macedonia and Educated females (as % of female labor force) in Turkey?
Your answer should be compact. 33.2. In the year 2009, what is the difference between the Educated females (as % of female labor force) of Slovak Republic and Educated females (as % of female labor force) of Turkey?
Ensure brevity in your answer.  56.3. In the year 2010, what is the difference between the Educated females (as % of female labor force) in Euro area and Educated females (as % of female labor force) in Macedonia?
Give a very brief answer. -5.85. In the year 2010, what is the difference between the Educated females (as % of female labor force) of Euro area and Educated females (as % of female labor force) of Slovak Republic?
Your answer should be compact. -26.25. In the year 2010, what is the difference between the Educated females (as % of female labor force) of Euro area and Educated females (as % of female labor force) of Turkey?
Your answer should be compact. 28.95. In the year 2010, what is the difference between the Educated females (as % of female labor force) in Macedonia and Educated females (as % of female labor force) in Slovak Republic?
Your response must be concise. -20.4. In the year 2010, what is the difference between the Educated females (as % of female labor force) of Macedonia and Educated females (as % of female labor force) of Turkey?
Your response must be concise. 34.8. In the year 2010, what is the difference between the Educated females (as % of female labor force) in Slovak Republic and Educated females (as % of female labor force) in Turkey?
Your answer should be very brief. 55.2. In the year 2011, what is the difference between the Educated females (as % of female labor force) of Euro area and Educated females (as % of female labor force) of Macedonia?
Make the answer very short. -4.31. In the year 2011, what is the difference between the Educated females (as % of female labor force) in Euro area and Educated females (as % of female labor force) in Slovak Republic?
Ensure brevity in your answer.  -24.51. In the year 2011, what is the difference between the Educated females (as % of female labor force) of Euro area and Educated females (as % of female labor force) of Turkey?
Give a very brief answer. 29.39. In the year 2011, what is the difference between the Educated females (as % of female labor force) of Macedonia and Educated females (as % of female labor force) of Slovak Republic?
Your answer should be compact. -20.2. In the year 2011, what is the difference between the Educated females (as % of female labor force) of Macedonia and Educated females (as % of female labor force) of Turkey?
Keep it short and to the point. 33.7. In the year 2011, what is the difference between the Educated females (as % of female labor force) in Slovak Republic and Educated females (as % of female labor force) in Turkey?
Make the answer very short. 53.9. In the year 2012, what is the difference between the Educated females (as % of female labor force) in Euro area and Educated females (as % of female labor force) in Macedonia?
Your answer should be compact. -5.54. In the year 2012, what is the difference between the Educated females (as % of female labor force) of Euro area and Educated females (as % of female labor force) of Slovak Republic?
Provide a short and direct response. -24.24. In the year 2012, what is the difference between the Educated females (as % of female labor force) in Euro area and Educated females (as % of female labor force) in Turkey?
Offer a very short reply. 29.26. In the year 2012, what is the difference between the Educated females (as % of female labor force) in Macedonia and Educated females (as % of female labor force) in Slovak Republic?
Offer a very short reply. -18.7. In the year 2012, what is the difference between the Educated females (as % of female labor force) in Macedonia and Educated females (as % of female labor force) in Turkey?
Offer a very short reply. 34.8. In the year 2012, what is the difference between the Educated females (as % of female labor force) of Slovak Republic and Educated females (as % of female labor force) of Turkey?
Keep it short and to the point. 53.5. In the year 2013, what is the difference between the Educated females (as % of female labor force) in Euro area and Educated females (as % of female labor force) in Macedonia?
Make the answer very short. -6.01. In the year 2013, what is the difference between the Educated females (as % of female labor force) in Euro area and Educated females (as % of female labor force) in Slovak Republic?
Offer a very short reply. -24.01. In the year 2013, what is the difference between the Educated females (as % of female labor force) in Euro area and Educated females (as % of female labor force) in Turkey?
Offer a very short reply. 28.79. In the year 2013, what is the difference between the Educated females (as % of female labor force) in Macedonia and Educated females (as % of female labor force) in Slovak Republic?
Offer a terse response. -18. In the year 2013, what is the difference between the Educated females (as % of female labor force) of Macedonia and Educated females (as % of female labor force) of Turkey?
Offer a very short reply. 34.8. In the year 2013, what is the difference between the Educated females (as % of female labor force) of Slovak Republic and Educated females (as % of female labor force) of Turkey?
Your response must be concise. 52.8. In the year 2014, what is the difference between the Educated females (as % of female labor force) of Euro area and Educated females (as % of female labor force) of Macedonia?
Give a very brief answer. -5.2. In the year 2014, what is the difference between the Educated females (as % of female labor force) of Euro area and Educated females (as % of female labor force) of Slovak Republic?
Keep it short and to the point. -22.9. In the year 2014, what is the difference between the Educated females (as % of female labor force) in Euro area and Educated females (as % of female labor force) in Turkey?
Provide a succinct answer. 29.2. In the year 2014, what is the difference between the Educated females (as % of female labor force) of Macedonia and Educated females (as % of female labor force) of Slovak Republic?
Ensure brevity in your answer.  -17.7. In the year 2014, what is the difference between the Educated females (as % of female labor force) in Macedonia and Educated females (as % of female labor force) in Turkey?
Offer a very short reply. 34.4. In the year 2014, what is the difference between the Educated females (as % of female labor force) in Slovak Republic and Educated females (as % of female labor force) in Turkey?
Your answer should be compact. 52.1. What is the ratio of the Educated females (as % of female labor force) of Euro area in 2007 to that in 2008?
Your response must be concise. 1. What is the ratio of the Educated females (as % of female labor force) of Macedonia in 2007 to that in 2008?
Give a very brief answer. 1.01. What is the ratio of the Educated females (as % of female labor force) in Slovak Republic in 2007 to that in 2008?
Give a very brief answer. 1. What is the ratio of the Educated females (as % of female labor force) of Turkey in 2007 to that in 2008?
Offer a very short reply. 1.01. What is the ratio of the Educated females (as % of female labor force) in Euro area in 2007 to that in 2009?
Make the answer very short. 1.01. What is the ratio of the Educated females (as % of female labor force) in Macedonia in 2007 to that in 2009?
Keep it short and to the point. 1.03. What is the ratio of the Educated females (as % of female labor force) in Turkey in 2007 to that in 2009?
Keep it short and to the point. 1.06. What is the ratio of the Educated females (as % of female labor force) in Euro area in 2007 to that in 2010?
Your answer should be very brief. 1.01. What is the ratio of the Educated females (as % of female labor force) of Macedonia in 2007 to that in 2010?
Your response must be concise. 1.02. What is the ratio of the Educated females (as % of female labor force) in Slovak Republic in 2007 to that in 2010?
Your answer should be compact. 1.04. What is the ratio of the Educated females (as % of female labor force) in Turkey in 2007 to that in 2010?
Provide a succinct answer. 1.15. What is the ratio of the Educated females (as % of female labor force) in Euro area in 2007 to that in 2011?
Provide a short and direct response. 1.01. What is the ratio of the Educated females (as % of female labor force) of Macedonia in 2007 to that in 2011?
Keep it short and to the point. 1.06. What is the ratio of the Educated females (as % of female labor force) of Slovak Republic in 2007 to that in 2011?
Offer a terse response. 1.07. What is the ratio of the Educated females (as % of female labor force) of Turkey in 2007 to that in 2011?
Offer a very short reply. 1.19. What is the ratio of the Educated females (as % of female labor force) in Euro area in 2007 to that in 2012?
Offer a very short reply. 1.02. What is the ratio of the Educated females (as % of female labor force) of Macedonia in 2007 to that in 2012?
Your answer should be compact. 1.04. What is the ratio of the Educated females (as % of female labor force) of Slovak Republic in 2007 to that in 2012?
Provide a succinct answer. 1.07. What is the ratio of the Educated females (as % of female labor force) in Turkey in 2007 to that in 2012?
Give a very brief answer. 1.2. What is the ratio of the Educated females (as % of female labor force) in Macedonia in 2007 to that in 2013?
Keep it short and to the point. 1.03. What is the ratio of the Educated females (as % of female labor force) in Slovak Republic in 2007 to that in 2013?
Offer a very short reply. 1.08. What is the ratio of the Educated females (as % of female labor force) of Turkey in 2007 to that in 2013?
Your answer should be very brief. 1.17. What is the ratio of the Educated females (as % of female labor force) in Euro area in 2007 to that in 2014?
Give a very brief answer. 1.01. What is the ratio of the Educated females (as % of female labor force) of Macedonia in 2007 to that in 2014?
Ensure brevity in your answer.  1.04. What is the ratio of the Educated females (as % of female labor force) in Slovak Republic in 2007 to that in 2014?
Provide a short and direct response. 1.09. What is the ratio of the Educated females (as % of female labor force) in Turkey in 2007 to that in 2014?
Offer a very short reply. 1.17. What is the ratio of the Educated females (as % of female labor force) in Euro area in 2008 to that in 2009?
Offer a very short reply. 1.01. What is the ratio of the Educated females (as % of female labor force) of Macedonia in 2008 to that in 2009?
Your answer should be very brief. 1.01. What is the ratio of the Educated females (as % of female labor force) of Slovak Republic in 2008 to that in 2009?
Ensure brevity in your answer.  1.01. What is the ratio of the Educated females (as % of female labor force) of Turkey in 2008 to that in 2009?
Keep it short and to the point. 1.05. What is the ratio of the Educated females (as % of female labor force) of Euro area in 2008 to that in 2010?
Your answer should be compact. 1.01. What is the ratio of the Educated females (as % of female labor force) in Macedonia in 2008 to that in 2010?
Your answer should be compact. 1.01. What is the ratio of the Educated females (as % of female labor force) in Slovak Republic in 2008 to that in 2010?
Your answer should be very brief. 1.04. What is the ratio of the Educated females (as % of female labor force) of Turkey in 2008 to that in 2010?
Your response must be concise. 1.14. What is the ratio of the Educated females (as % of female labor force) of Euro area in 2008 to that in 2011?
Ensure brevity in your answer.  1.01. What is the ratio of the Educated females (as % of female labor force) of Macedonia in 2008 to that in 2011?
Ensure brevity in your answer.  1.04. What is the ratio of the Educated females (as % of female labor force) of Slovak Republic in 2008 to that in 2011?
Your answer should be compact. 1.07. What is the ratio of the Educated females (as % of female labor force) of Turkey in 2008 to that in 2011?
Give a very brief answer. 1.18. What is the ratio of the Educated females (as % of female labor force) in Euro area in 2008 to that in 2012?
Your response must be concise. 1.02. What is the ratio of the Educated females (as % of female labor force) in Macedonia in 2008 to that in 2012?
Offer a very short reply. 1.03. What is the ratio of the Educated females (as % of female labor force) of Slovak Republic in 2008 to that in 2012?
Provide a succinct answer. 1.08. What is the ratio of the Educated females (as % of female labor force) in Turkey in 2008 to that in 2012?
Give a very brief answer. 1.19. What is the ratio of the Educated females (as % of female labor force) in Euro area in 2008 to that in 2013?
Your answer should be very brief. 1.02. What is the ratio of the Educated females (as % of female labor force) in Macedonia in 2008 to that in 2013?
Give a very brief answer. 1.02. What is the ratio of the Educated females (as % of female labor force) in Slovak Republic in 2008 to that in 2013?
Keep it short and to the point. 1.08. What is the ratio of the Educated females (as % of female labor force) in Turkey in 2008 to that in 2013?
Offer a very short reply. 1.16. What is the ratio of the Educated females (as % of female labor force) in Macedonia in 2008 to that in 2014?
Keep it short and to the point. 1.02. What is the ratio of the Educated females (as % of female labor force) of Slovak Republic in 2008 to that in 2014?
Offer a very short reply. 1.09. What is the ratio of the Educated females (as % of female labor force) in Turkey in 2008 to that in 2014?
Your answer should be very brief. 1.16. What is the ratio of the Educated females (as % of female labor force) in Euro area in 2009 to that in 2010?
Give a very brief answer. 1. What is the ratio of the Educated females (as % of female labor force) of Macedonia in 2009 to that in 2010?
Make the answer very short. 1. What is the ratio of the Educated females (as % of female labor force) of Slovak Republic in 2009 to that in 2010?
Provide a succinct answer. 1.03. What is the ratio of the Educated females (as % of female labor force) of Turkey in 2009 to that in 2010?
Offer a terse response. 1.08. What is the ratio of the Educated females (as % of female labor force) of Macedonia in 2009 to that in 2011?
Give a very brief answer. 1.03. What is the ratio of the Educated females (as % of female labor force) in Slovak Republic in 2009 to that in 2011?
Provide a short and direct response. 1.06. What is the ratio of the Educated females (as % of female labor force) in Turkey in 2009 to that in 2011?
Provide a succinct answer. 1.12. What is the ratio of the Educated females (as % of female labor force) in Euro area in 2009 to that in 2012?
Make the answer very short. 1.01. What is the ratio of the Educated females (as % of female labor force) in Macedonia in 2009 to that in 2012?
Keep it short and to the point. 1.01. What is the ratio of the Educated females (as % of female labor force) of Slovak Republic in 2009 to that in 2012?
Provide a succinct answer. 1.07. What is the ratio of the Educated females (as % of female labor force) in Turkey in 2009 to that in 2012?
Make the answer very short. 1.14. What is the ratio of the Educated females (as % of female labor force) in Euro area in 2009 to that in 2013?
Give a very brief answer. 1.01. What is the ratio of the Educated females (as % of female labor force) of Slovak Republic in 2009 to that in 2013?
Provide a succinct answer. 1.07. What is the ratio of the Educated females (as % of female labor force) of Turkey in 2009 to that in 2013?
Give a very brief answer. 1.1. What is the ratio of the Educated females (as % of female labor force) of Euro area in 2009 to that in 2014?
Keep it short and to the point. 1. What is the ratio of the Educated females (as % of female labor force) in Macedonia in 2009 to that in 2014?
Your answer should be compact. 1.01. What is the ratio of the Educated females (as % of female labor force) of Slovak Republic in 2009 to that in 2014?
Provide a short and direct response. 1.09. What is the ratio of the Educated females (as % of female labor force) in Turkey in 2009 to that in 2014?
Give a very brief answer. 1.1. What is the ratio of the Educated females (as % of female labor force) in Euro area in 2010 to that in 2011?
Make the answer very short. 1. What is the ratio of the Educated females (as % of female labor force) in Macedonia in 2010 to that in 2011?
Make the answer very short. 1.03. What is the ratio of the Educated females (as % of female labor force) of Slovak Republic in 2010 to that in 2011?
Ensure brevity in your answer.  1.03. What is the ratio of the Educated females (as % of female labor force) in Turkey in 2010 to that in 2011?
Your answer should be very brief. 1.04. What is the ratio of the Educated females (as % of female labor force) in Euro area in 2010 to that in 2012?
Keep it short and to the point. 1.01. What is the ratio of the Educated females (as % of female labor force) of Macedonia in 2010 to that in 2012?
Offer a terse response. 1.02. What is the ratio of the Educated females (as % of female labor force) in Slovak Republic in 2010 to that in 2012?
Make the answer very short. 1.04. What is the ratio of the Educated females (as % of female labor force) of Turkey in 2010 to that in 2012?
Make the answer very short. 1.05. What is the ratio of the Educated females (as % of female labor force) of Euro area in 2010 to that in 2013?
Your response must be concise. 1.01. What is the ratio of the Educated females (as % of female labor force) in Macedonia in 2010 to that in 2013?
Your answer should be very brief. 1.01. What is the ratio of the Educated females (as % of female labor force) in Slovak Republic in 2010 to that in 2013?
Provide a short and direct response. 1.04. What is the ratio of the Educated females (as % of female labor force) in Turkey in 2010 to that in 2013?
Give a very brief answer. 1.02. What is the ratio of the Educated females (as % of female labor force) of Euro area in 2010 to that in 2014?
Provide a succinct answer. 1. What is the ratio of the Educated females (as % of female labor force) of Macedonia in 2010 to that in 2014?
Keep it short and to the point. 1.01. What is the ratio of the Educated females (as % of female labor force) in Slovak Republic in 2010 to that in 2014?
Give a very brief answer. 1.05. What is the ratio of the Educated females (as % of female labor force) of Euro area in 2011 to that in 2012?
Ensure brevity in your answer.  1.01. What is the ratio of the Educated females (as % of female labor force) of Macedonia in 2011 to that in 2012?
Make the answer very short. 0.98. What is the ratio of the Educated females (as % of female labor force) of Slovak Republic in 2011 to that in 2012?
Provide a short and direct response. 1.01. What is the ratio of the Educated females (as % of female labor force) of Turkey in 2011 to that in 2012?
Ensure brevity in your answer.  1.01. What is the ratio of the Educated females (as % of female labor force) in Euro area in 2011 to that in 2013?
Your answer should be compact. 1.01. What is the ratio of the Educated females (as % of female labor force) in Macedonia in 2011 to that in 2013?
Your answer should be compact. 0.97. What is the ratio of the Educated females (as % of female labor force) of Slovak Republic in 2011 to that in 2013?
Offer a terse response. 1.01. What is the ratio of the Educated females (as % of female labor force) in Macedonia in 2011 to that in 2014?
Your answer should be very brief. 0.98. What is the ratio of the Educated females (as % of female labor force) of Slovak Republic in 2011 to that in 2014?
Offer a terse response. 1.02. What is the ratio of the Educated females (as % of female labor force) in Turkey in 2011 to that in 2014?
Make the answer very short. 0.98. What is the ratio of the Educated females (as % of female labor force) of Euro area in 2012 to that in 2013?
Offer a terse response. 1. What is the ratio of the Educated females (as % of female labor force) of Macedonia in 2012 to that in 2013?
Provide a succinct answer. 0.99. What is the ratio of the Educated females (as % of female labor force) in Turkey in 2012 to that in 2013?
Keep it short and to the point. 0.97. What is the ratio of the Educated females (as % of female labor force) in Euro area in 2012 to that in 2014?
Your answer should be compact. 0.99. What is the ratio of the Educated females (as % of female labor force) of Macedonia in 2012 to that in 2014?
Your answer should be very brief. 1. What is the ratio of the Educated females (as % of female labor force) in Slovak Republic in 2012 to that in 2014?
Offer a terse response. 1.01. What is the ratio of the Educated females (as % of female labor force) of Turkey in 2012 to that in 2014?
Provide a succinct answer. 0.97. What is the ratio of the Educated females (as % of female labor force) of Slovak Republic in 2013 to that in 2014?
Provide a succinct answer. 1.01. What is the difference between the highest and the second highest Educated females (as % of female labor force) in Euro area?
Ensure brevity in your answer.  0.08. What is the difference between the highest and the second highest Educated females (as % of female labor force) in Turkey?
Make the answer very short. 0.2. What is the difference between the highest and the lowest Educated females (as % of female labor force) in Euro area?
Make the answer very short. 0.94. What is the difference between the highest and the lowest Educated females (as % of female labor force) of Macedonia?
Keep it short and to the point. 2.9. 